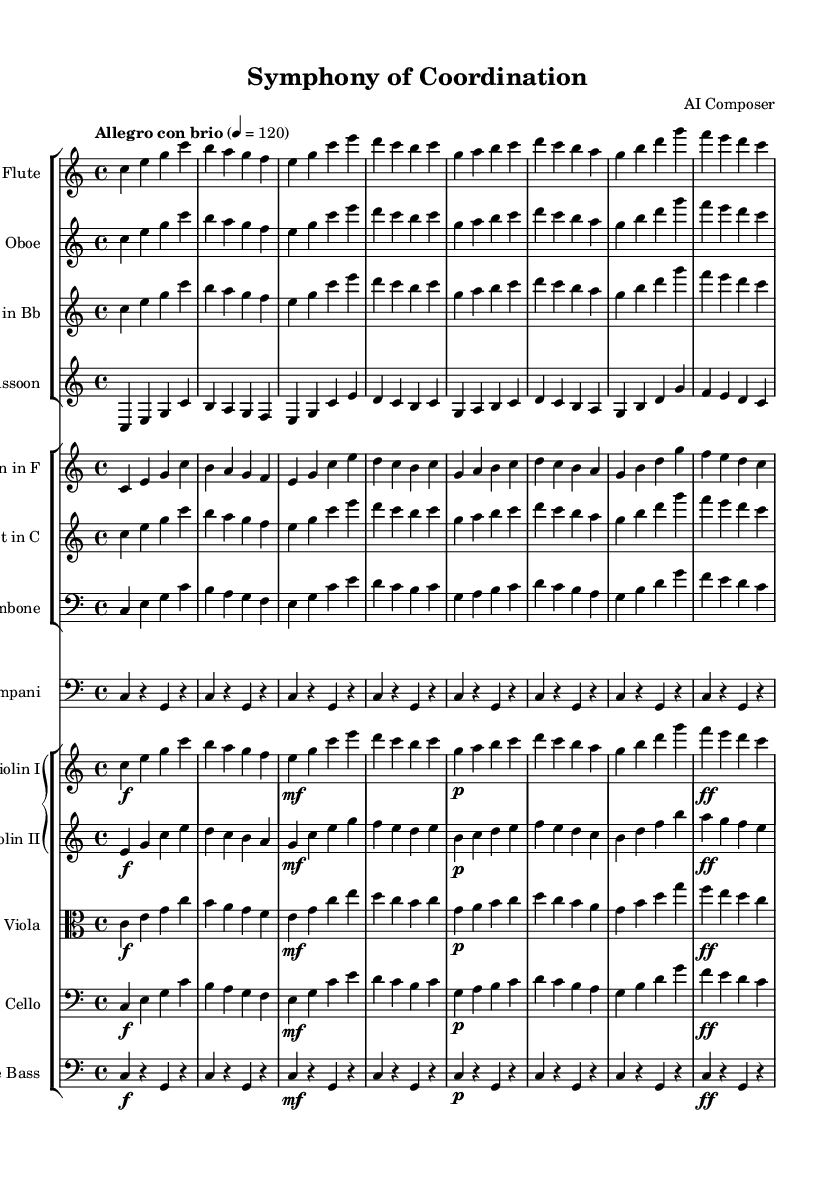What is the key signature of this music? The key signature is C major, which has no sharps or flats.
Answer: C major What is the time signature of the piece? The time signature shown is 4/4, indicating four beats per measure.
Answer: 4/4 What is the tempo marking for this symphony? The tempo marking is "Allegro con brio," which indicates a lively and brisk pace.
Answer: Allegro con brio How many measures are presented in the first complete section? Counting the measures in the first section, there are eight measures total.
Answer: 8 Which instrument has the highest pitch in this piece? The flute, found in the treble clef, has the highest pitch compared to the other instruments shown.
Answer: Flute What dynamic marking is indicated for the first violin in the fourth measure? The first violin has a dynamic of forte (indicated by "f"), meaning it should be played loudly.
Answer: forte How do the dynamics change throughout the piece? The dynamics range from forte to piano, indicating a contrast between loud and soft sounds, with markings such as "mf" (mezzo-forte) and "p" (piano) present.
Answer: Contrast 